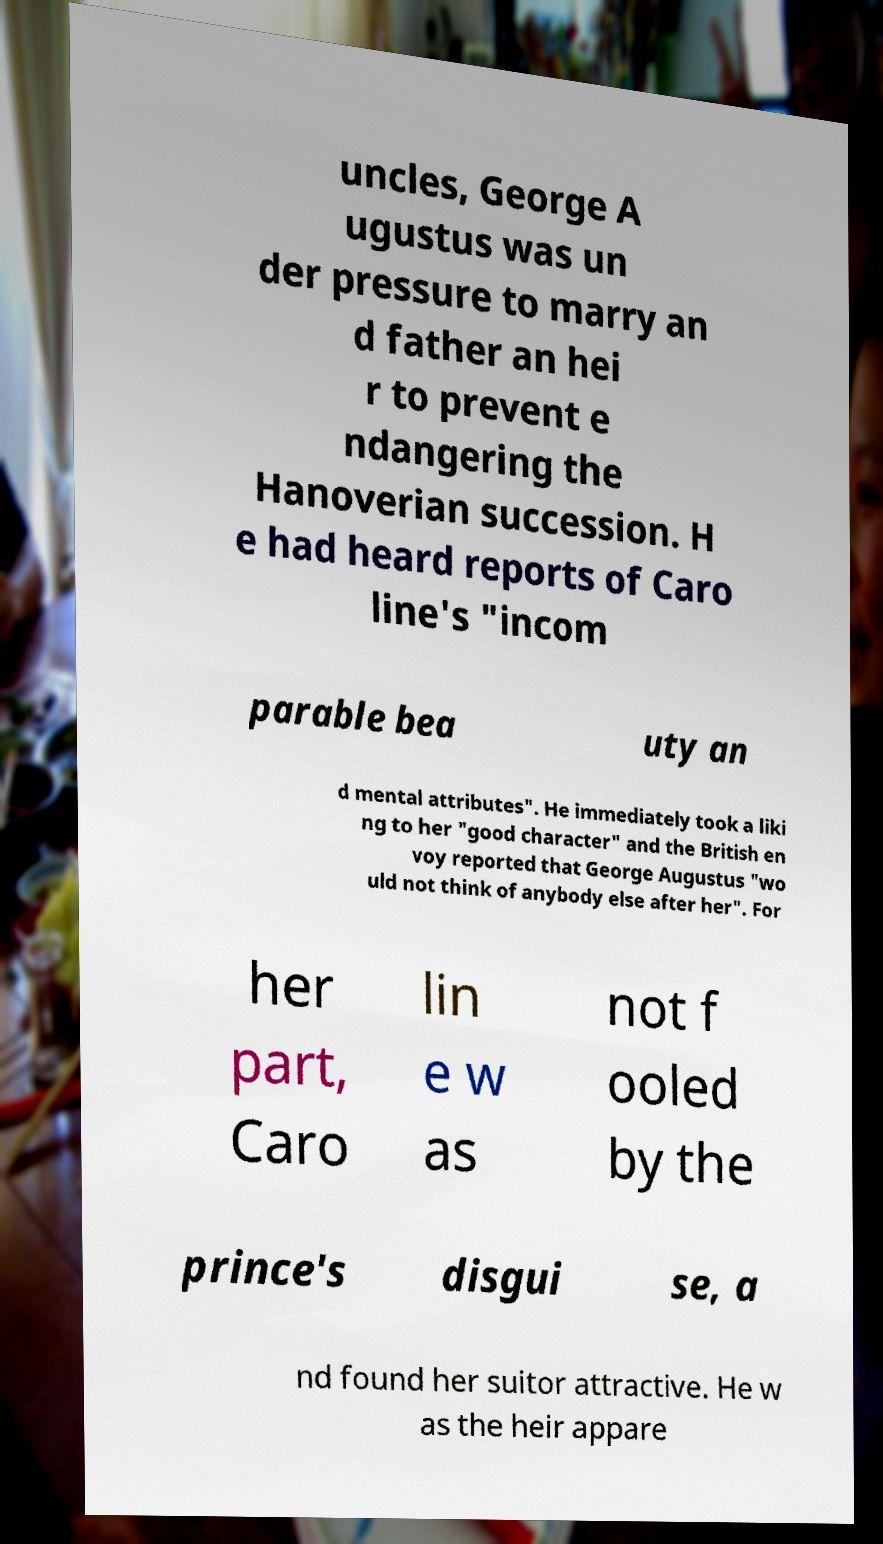Please read and relay the text visible in this image. What does it say? uncles, George A ugustus was un der pressure to marry an d father an hei r to prevent e ndangering the Hanoverian succession. H e had heard reports of Caro line's "incom parable bea uty an d mental attributes". He immediately took a liki ng to her "good character" and the British en voy reported that George Augustus "wo uld not think of anybody else after her". For her part, Caro lin e w as not f ooled by the prince's disgui se, a nd found her suitor attractive. He w as the heir appare 